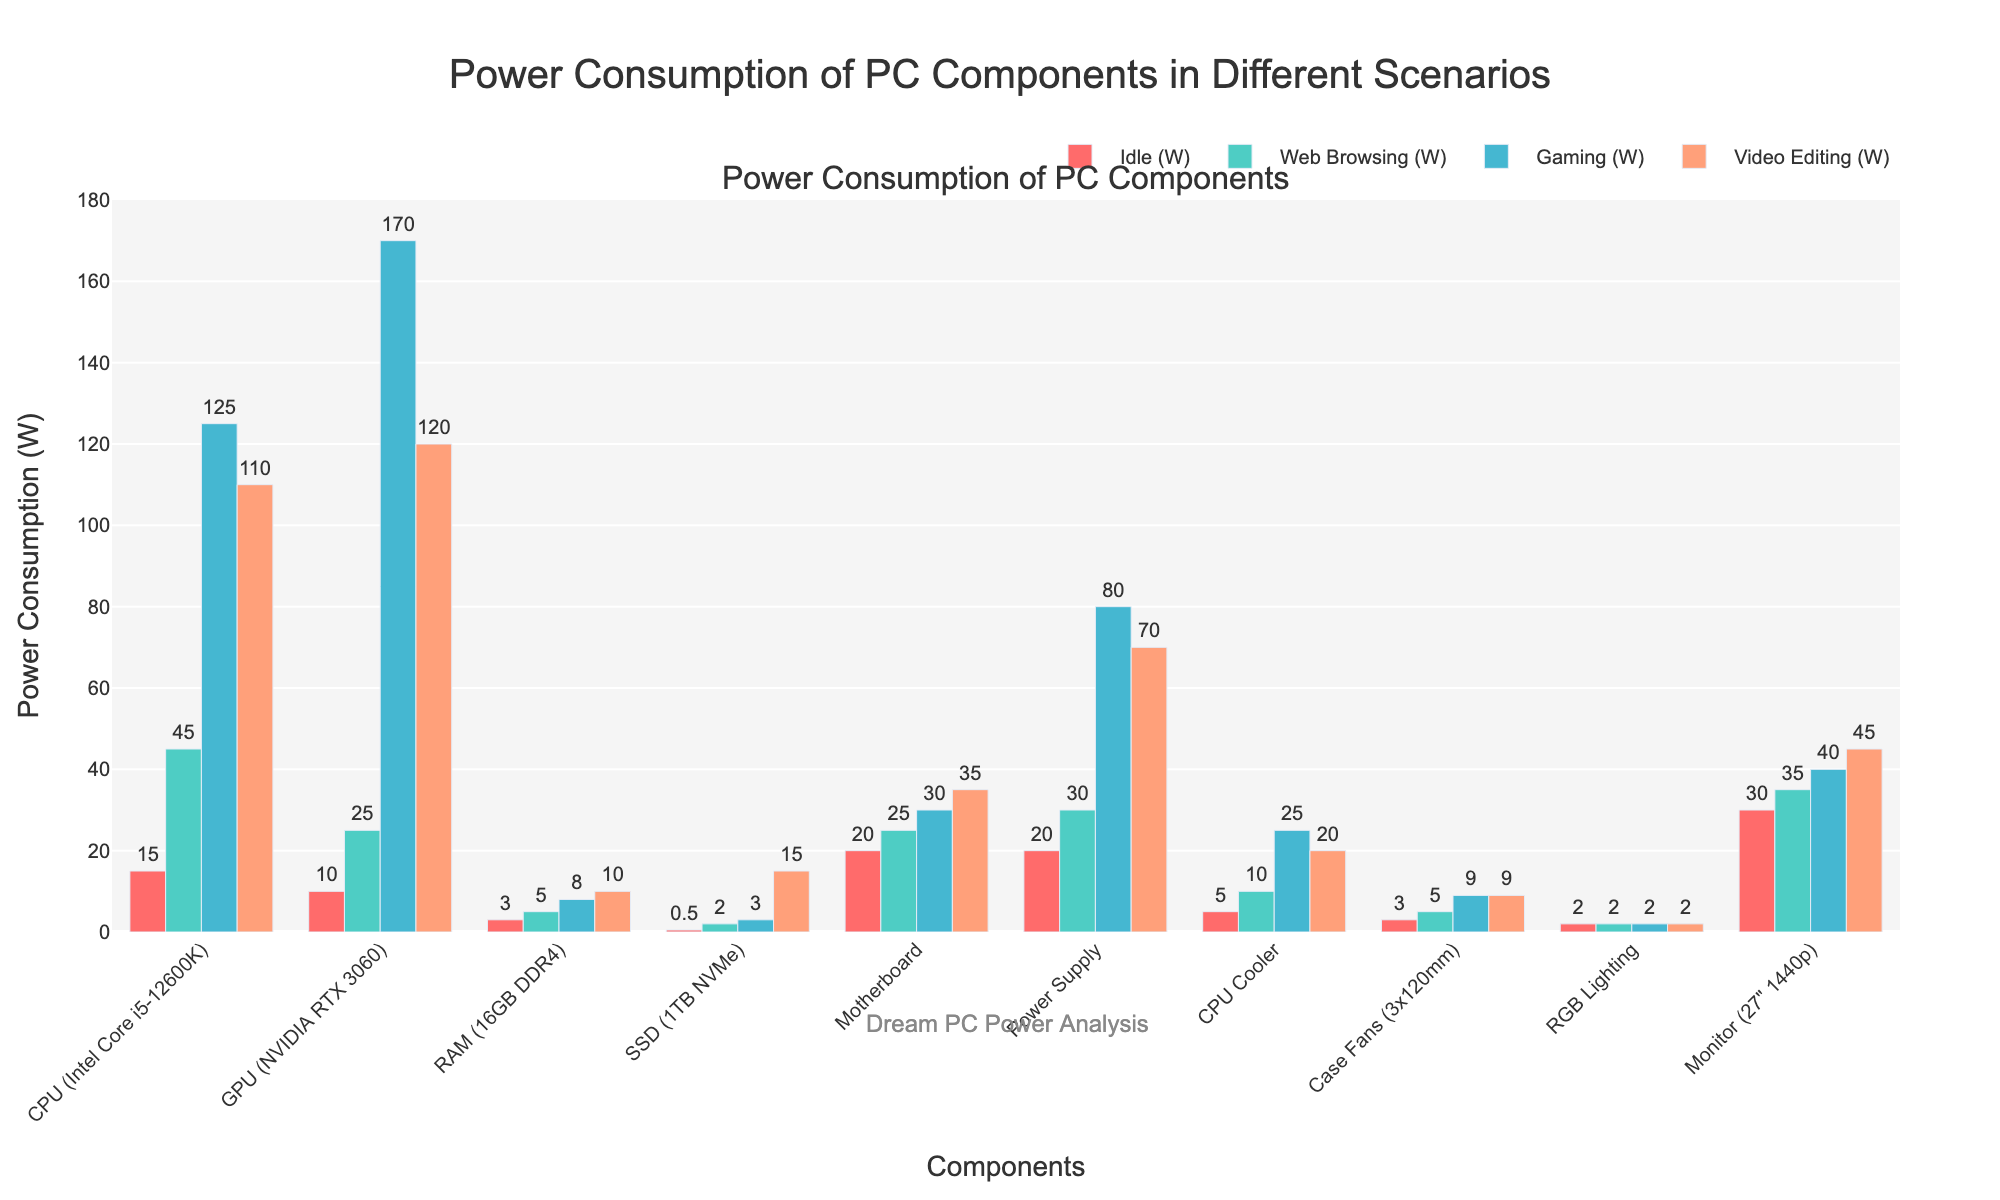Which component has the highest power consumption during gaming? By observing the height of the bars for the gaming scenario, the GPU (NVIDIA RTX 3060) has the highest bar, indicating it consumes the most power during gaming.
Answer: GPU (NVIDIA RTX 3060) What is the average power consumption of the CPU (Intel Core i5-12600K) across all scenarios? Adding the CPU's power consumption values across all scenarios (15W + 45W + 125W + 110W) equals 295W, and dividing by the number of scenarios (4) gives an average of 295W / 4 = 73.75W.
Answer: 73.75W Which scenario results in the highest total power consumption across all components combined? By summing the power consumption values for all components within each scenario: Idle = (108.5), Web Browsing = (209), Gaming = (512), Video Editing = (436). The highest total is for the Gaming scenario with 512W.
Answer: Gaming How much more power does the GPU (NVIDIA RTX 3060) consume compared to the CPU (Intel Core i5-12600K) during gaming? Subtracting the CPU's gaming power consumption (125W) from the GPU's gaming power consumption (170W) gives 170W - 125W = 45W.
Answer: 45W Which component has the least variation in power consumption across different scenarios? By observing the differences in the heights of bars across scenarios, RGB Lighting has consistent power consumption (2W) across all scenarios, indicating no variation.
Answer: RGB Lighting How much total power is consumed by the SSD (1TB NVMe) across all scenarios? Summing the SSD's power consumption values across all scenarios (0.5W + 2W + 3W + 15W) gives a total of 20.5W.
Answer: 20.5W Which two components consume the same amount of power during web browsing? By observing the height of the bars for web browsing, the RAM (16GB DDR4) and Case Fans (3x120mm) both have bars with the same height, indicating identical power consumption (5W).
Answer: RAM (16GB DDR4) and Case Fans (3x120mm) What is the difference in power consumption between the Power Supply during video editing and idle scenarios? Subtracting the idle power consumption (20W) from the video editing power consumption (70W) for the Power Supply gives 70W - 20W = 50W.
Answer: 50W Which component consumes the most power during idle? By observing the height of the bars in the Idle scenario, the Monitor (27" 1440p) has the highest bar, indicating it consumes the most power during idle.
Answer: Monitor (27" 1440p) 